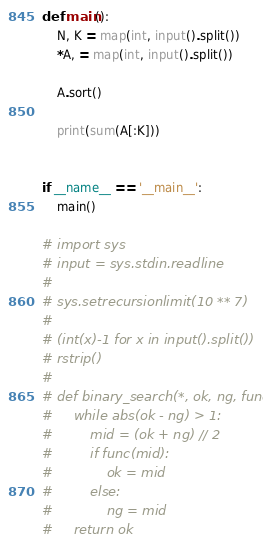Convert code to text. <code><loc_0><loc_0><loc_500><loc_500><_Python_>def main():
    N, K = map(int, input().split())
    *A, = map(int, input().split())

    A.sort()

    print(sum(A[:K]))


if __name__ == '__main__':
    main()

# import sys
# input = sys.stdin.readline
# 
# sys.setrecursionlimit(10 ** 7)
# 
# (int(x)-1 for x in input().split())
# rstrip()
#
# def binary_search(*, ok, ng, func):
#     while abs(ok - ng) > 1:
#         mid = (ok + ng) // 2
#         if func(mid):
#             ok = mid
#         else:
#             ng = mid
#     return ok
</code> 